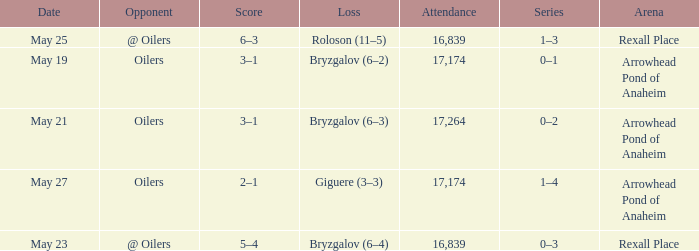What was the attendance on may 21? 17264.0. 